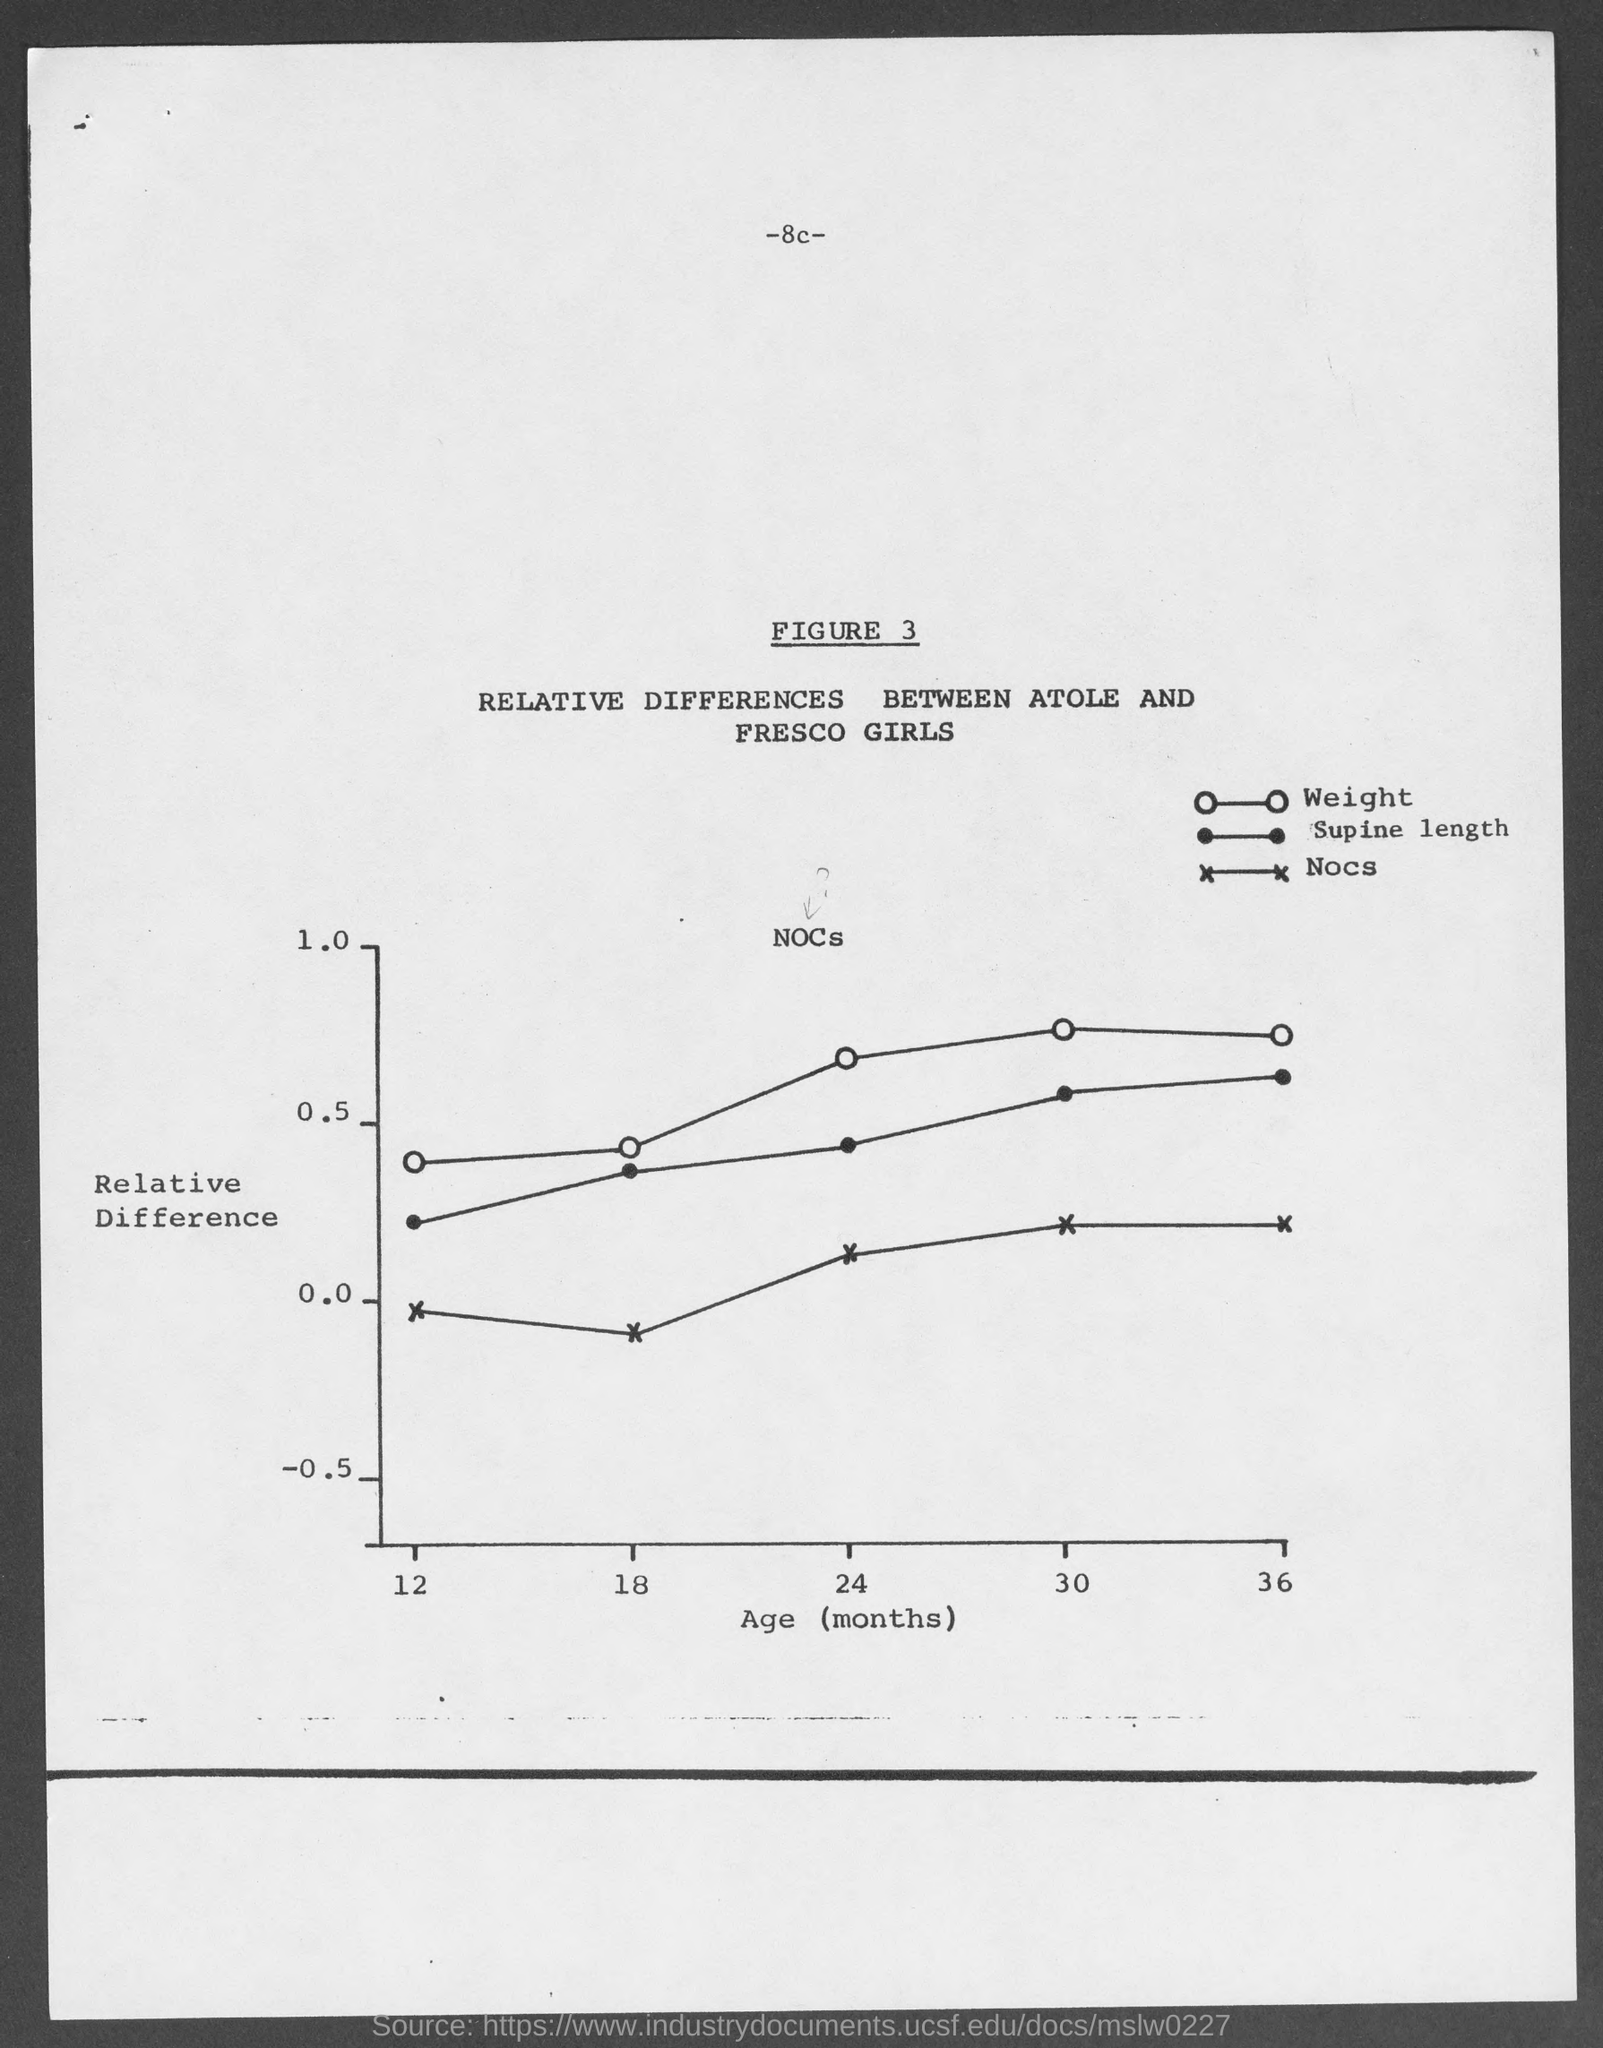How do the Atole and Fresco girls differ based on this figure? Based on Figure 3, it appears that over the ages of 12 to 36 months, Atole girls may have a relative increase in weight and supine length compared to Fresco girls. The data shows a positive trend in these two measurements, which indicates that Atole girls might be experiencing greater growth in these areas over the specified age range. 